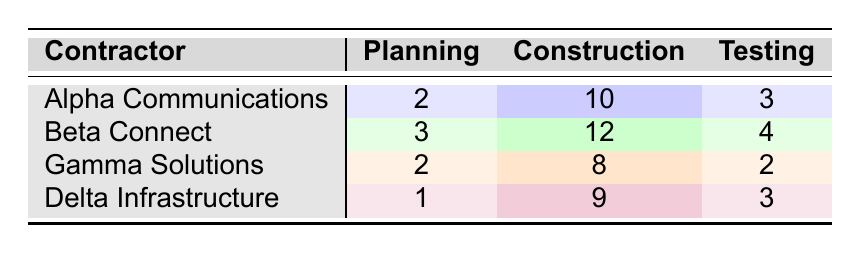What is the average duration of the Planning stage for all contractors? To calculate the average duration of the Planning stage, we first find the durations: Alpha Communications is 2 weeks, Beta Connect is 3 weeks, Gamma Solutions is 2 weeks, and Delta Infrastructure is 1 week. Adding these gives us 2 + 3 + 2 + 1 = 8 weeks. There are 4 contractors, so the average is 8/4 = 2 weeks.
Answer: 2 weeks Which contractor has the longest average duration in the Construction stage? To determine which contractor has the longest duration in the Construction stage, we compare the values: Alpha Communications has 10 weeks, Beta Connect has 12 weeks, Gamma Solutions has 8 weeks, and Delta Infrastructure has 9 weeks. The longest is 12 weeks from Beta Connect.
Answer: Beta Connect Is the average duration of the Testing stage for Gamma Solutions less than that of Alpha Communications? Gamma Solutions has an average duration of 2 weeks in the Testing stage. Alpha Communications has an average of 3 weeks. Since 2 is less than 3, the statement is true.
Answer: Yes What is the total duration of the Construction stage across all contractors? To find the total duration for the Construction stage, we sum the values: Alpha Communications (10 weeks) + Beta Connect (12 weeks) + Gamma Solutions (8 weeks) + Delta Infrastructure (9 weeks). Summing these gives us 10 + 12 + 8 + 9 = 39 weeks.
Answer: 39 weeks Which contractor has the smallest difference between Planning and Testing stage durations? We calculate the difference for each contractor: Alpha Communications (2 - 3 = -1 weeks), Beta Connect (3 - 4 = -1 weeks), Gamma Solutions (2 - 2 = 0 weeks), and Delta Infrastructure (1 - 3 = -2 weeks). The smallest difference is 0 weeks for Gamma Solutions.
Answer: Gamma Solutions 